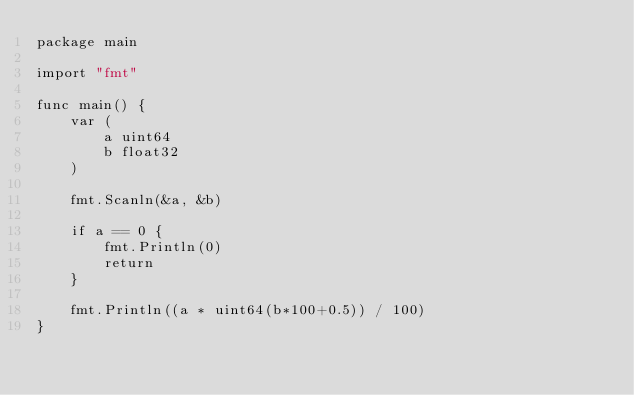<code> <loc_0><loc_0><loc_500><loc_500><_Go_>package main

import "fmt"

func main() {
	var (
		a uint64
		b float32
	)

	fmt.Scanln(&a, &b)

	if a == 0 {
		fmt.Println(0)
		return
	}

	fmt.Println((a * uint64(b*100+0.5)) / 100)
}</code> 